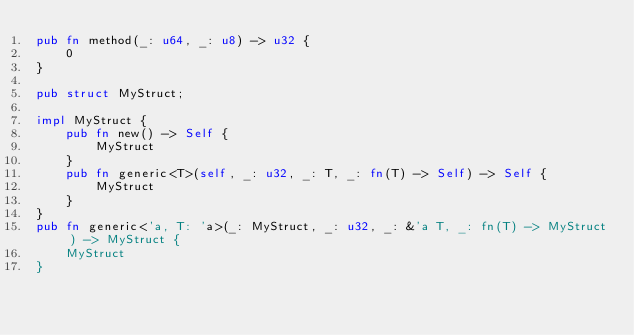Convert code to text. <code><loc_0><loc_0><loc_500><loc_500><_Rust_>pub fn method(_: u64, _: u8) -> u32 {
	0
}

pub struct MyStruct;

impl MyStruct {
	pub fn new() -> Self {
		MyStruct
	}
	pub fn generic<T>(self, _: u32, _: T, _: fn(T) -> Self) -> Self {
		MyStruct
	}
}
pub fn generic<'a, T: 'a>(_: MyStruct, _: u32, _: &'a T, _: fn(T) -> MyStruct) -> MyStruct {
	MyStruct
}</code> 